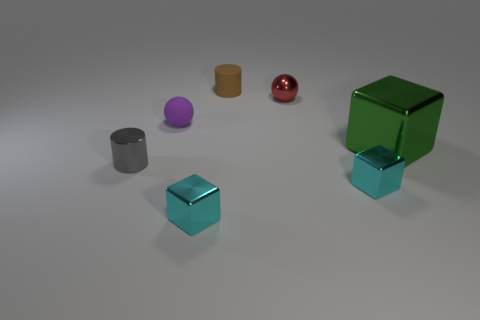What is the material of the object that is to the left of the matte cylinder and behind the green cube?
Keep it short and to the point. Rubber. Does the brown cylinder have the same material as the small purple sphere?
Keep it short and to the point. Yes. What number of large shiny cubes are there?
Provide a short and direct response. 1. There is a small cylinder to the right of the tiny metal cylinder in front of the cube that is behind the small metallic cylinder; what is its color?
Your answer should be very brief. Brown. How many tiny objects are to the right of the tiny red thing and behind the shiny cylinder?
Your response must be concise. 0. How many metallic things are purple objects or small brown cubes?
Offer a very short reply. 0. What material is the cube behind the tiny cylinder that is in front of the big green shiny thing made of?
Offer a very short reply. Metal. There is a brown thing that is the same size as the red metallic sphere; what is its shape?
Your response must be concise. Cylinder. Is the number of small cyan matte blocks less than the number of brown rubber objects?
Your answer should be very brief. Yes. There is a tiny shiny block that is left of the rubber cylinder; are there any purple things that are in front of it?
Make the answer very short. No. 